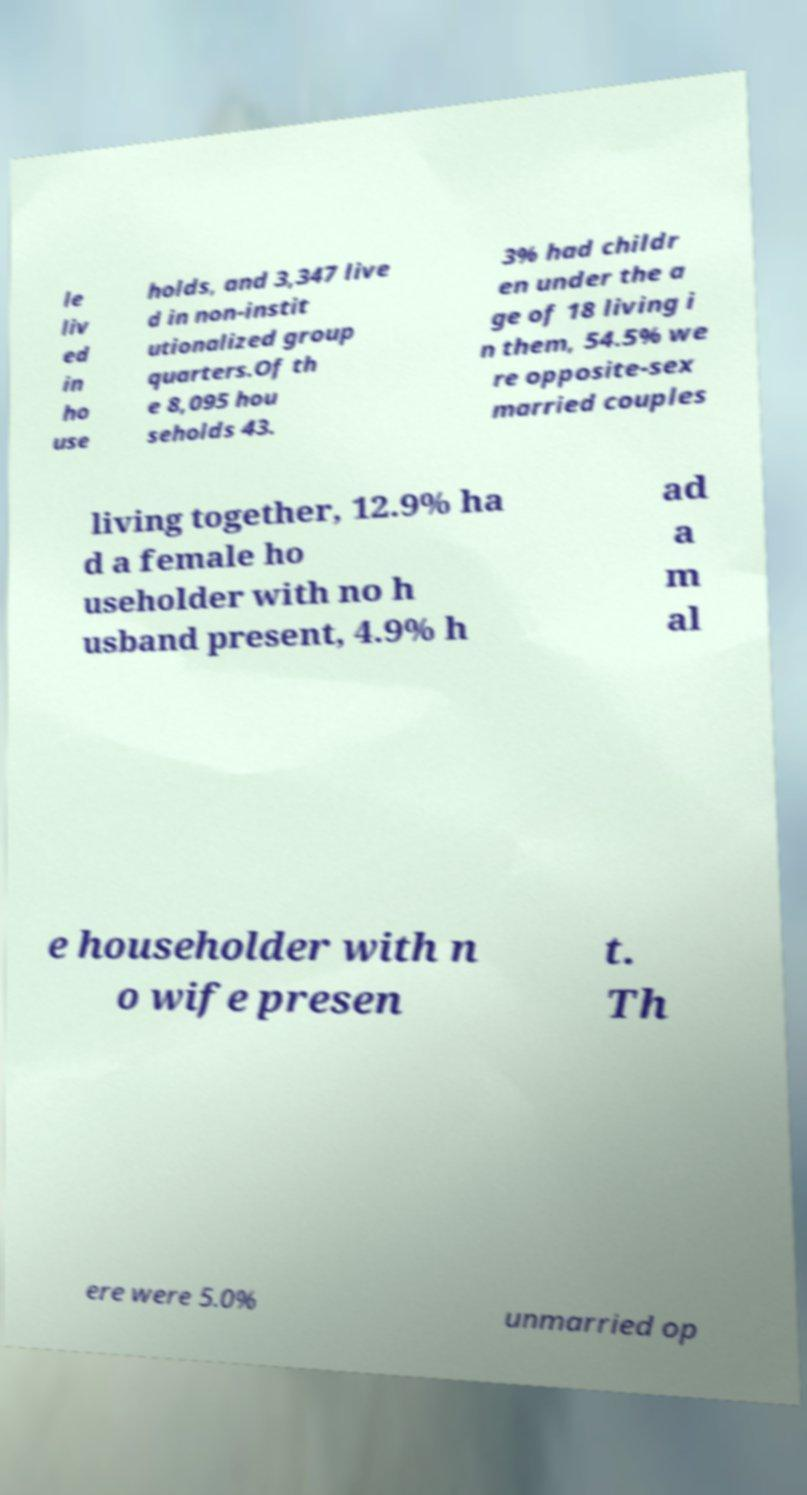I need the written content from this picture converted into text. Can you do that? le liv ed in ho use holds, and 3,347 live d in non-instit utionalized group quarters.Of th e 8,095 hou seholds 43. 3% had childr en under the a ge of 18 living i n them, 54.5% we re opposite-sex married couples living together, 12.9% ha d a female ho useholder with no h usband present, 4.9% h ad a m al e householder with n o wife presen t. Th ere were 5.0% unmarried op 